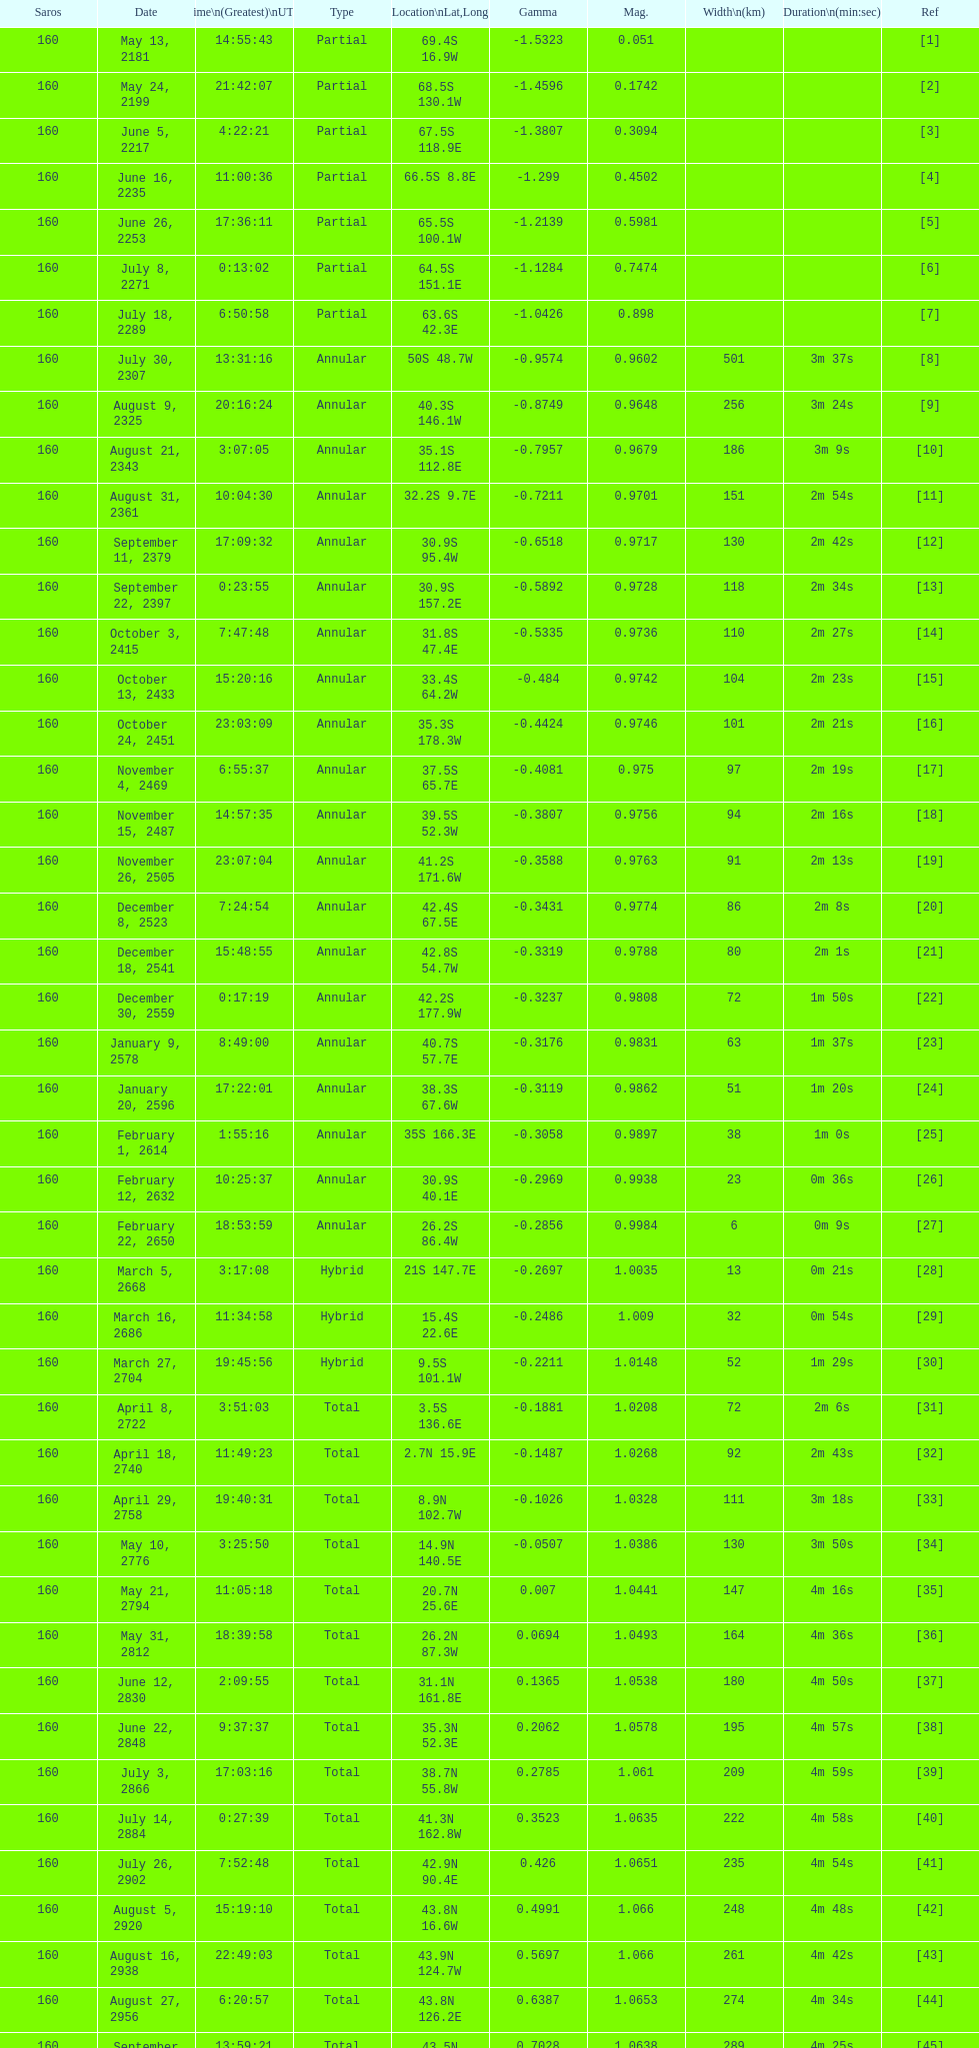How long did 18 last? 2m 16s. 